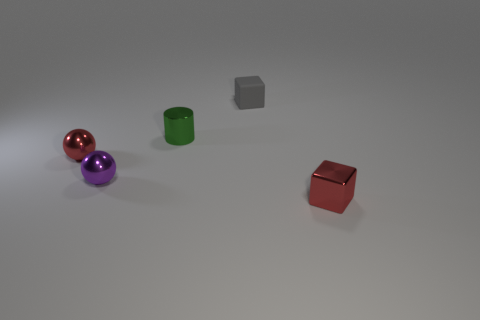Subtract all cubes. How many objects are left? 3 Subtract 1 spheres. How many spheres are left? 1 Add 3 red rubber blocks. How many red rubber blocks exist? 3 Add 1 blocks. How many objects exist? 6 Subtract 0 brown cubes. How many objects are left? 5 Subtract all cyan cylinders. Subtract all purple blocks. How many cylinders are left? 1 Subtract all brown cubes. How many cyan cylinders are left? 0 Subtract all small red matte cubes. Subtract all shiny cubes. How many objects are left? 4 Add 2 small green shiny things. How many small green shiny things are left? 3 